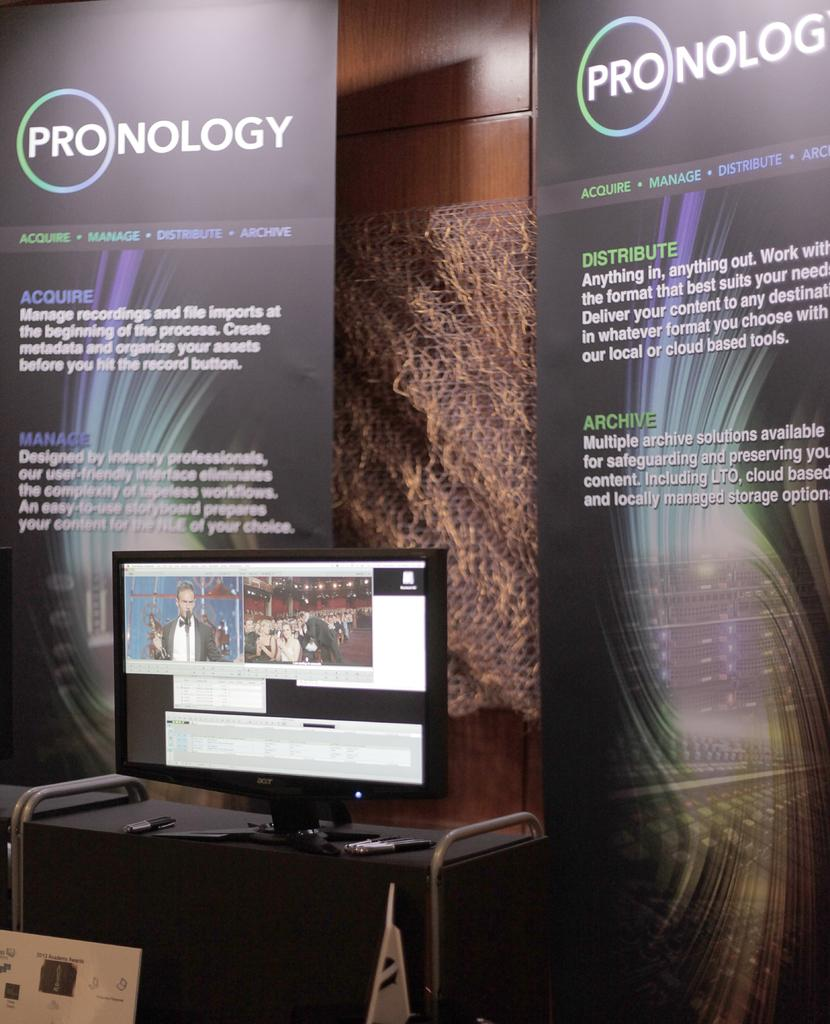What type of device is in the image? There is a black color monitor in the image. Where is the monitor located? The monitor is placed on a table. Are there any other items in the image that are similar in color? Yes, there are two black color posters in the image. What type of oven is visible in the image? There is no oven present in the image. 